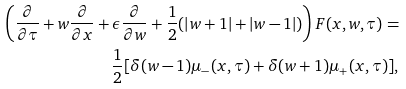Convert formula to latex. <formula><loc_0><loc_0><loc_500><loc_500>\left ( \frac { \partial } { \partial \tau } + w \frac { \partial } { \partial x } + \epsilon \frac { \partial } { \partial w } + \frac { 1 } { 2 } ( | w + 1 | + | w - 1 | ) \right ) F ( x , w , \tau ) = & \\ \quad \frac { 1 } { 2 } [ \delta ( w - 1 ) \mu _ { - } ( x , \tau ) + \delta ( w + 1 ) \mu _ { + } ( x , \tau ) ] , &</formula> 